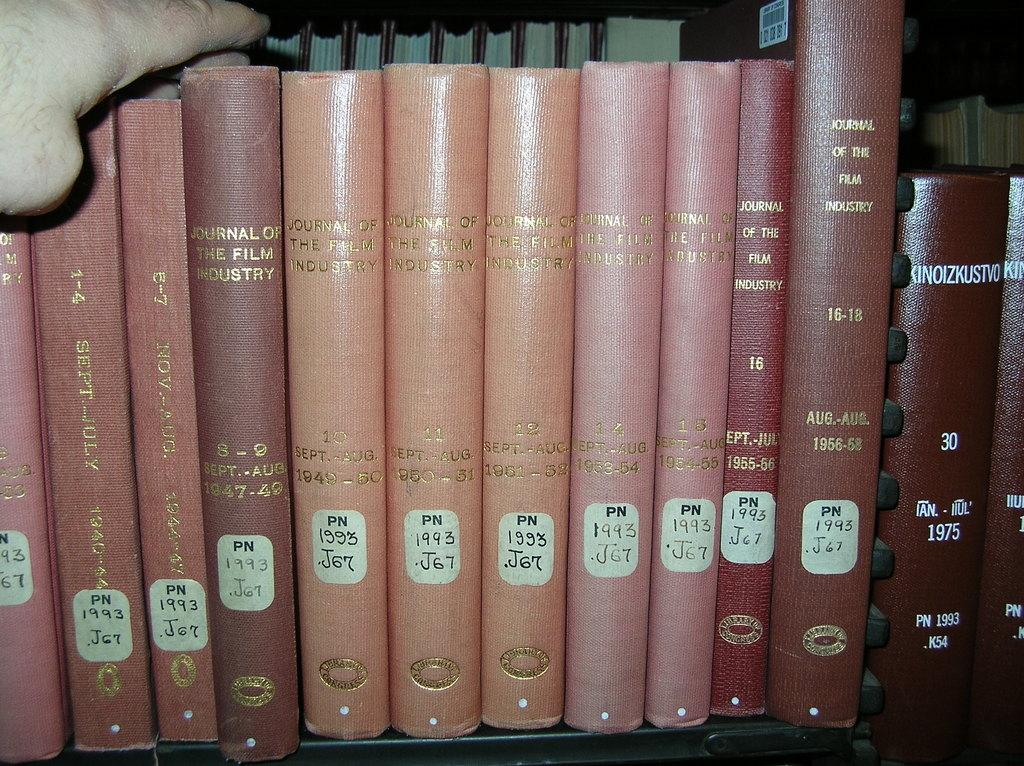What objects are on the rack in the image? There are books on a rack in the image. Can you describe any other elements in the image? Yes, there is a hand of a person visible in the image. What type of patch can be seen on the books in the image? There is no patch visible on the books in the image. 